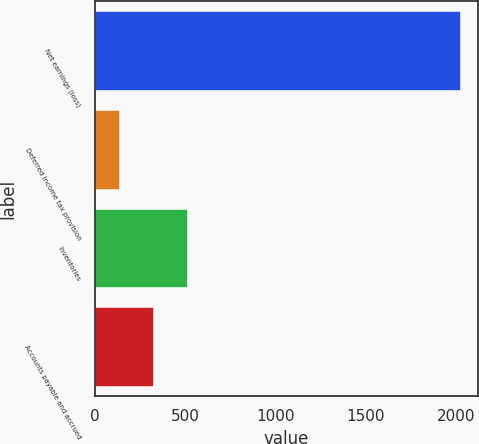Convert chart. <chart><loc_0><loc_0><loc_500><loc_500><bar_chart><fcel>Net earnings (loss)<fcel>Deferred income tax provision<fcel>Inventories<fcel>Accounts payable and accrued<nl><fcel>2017<fcel>133<fcel>509.8<fcel>321.4<nl></chart> 